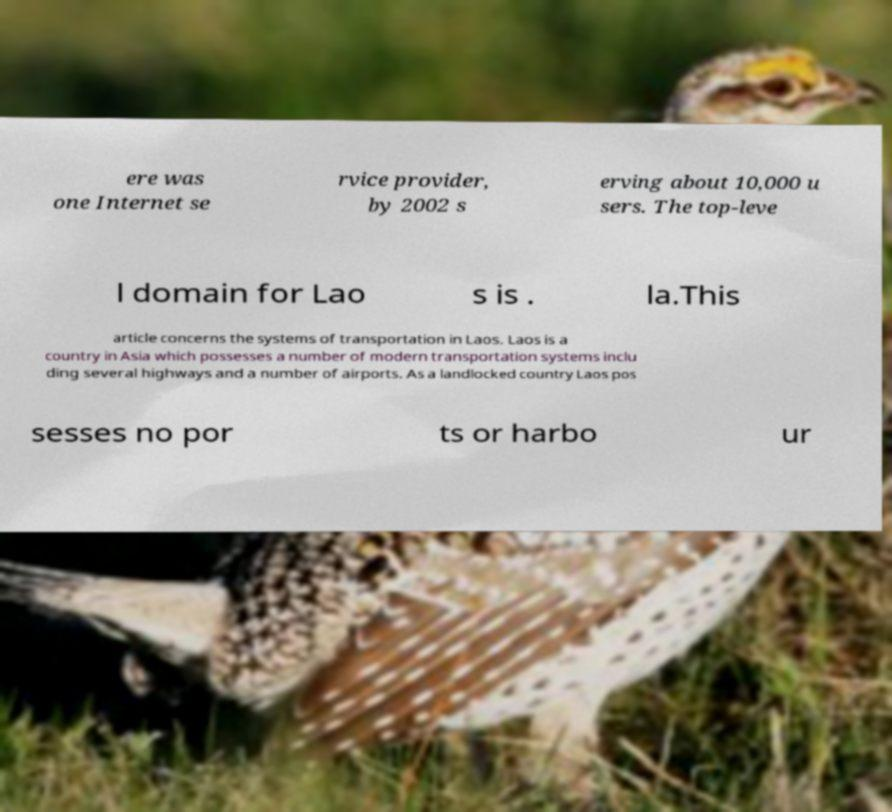I need the written content from this picture converted into text. Can you do that? ere was one Internet se rvice provider, by 2002 s erving about 10,000 u sers. The top-leve l domain for Lao s is . la.This article concerns the systems of transportation in Laos. Laos is a country in Asia which possesses a number of modern transportation systems inclu ding several highways and a number of airports. As a landlocked country Laos pos sesses no por ts or harbo ur 